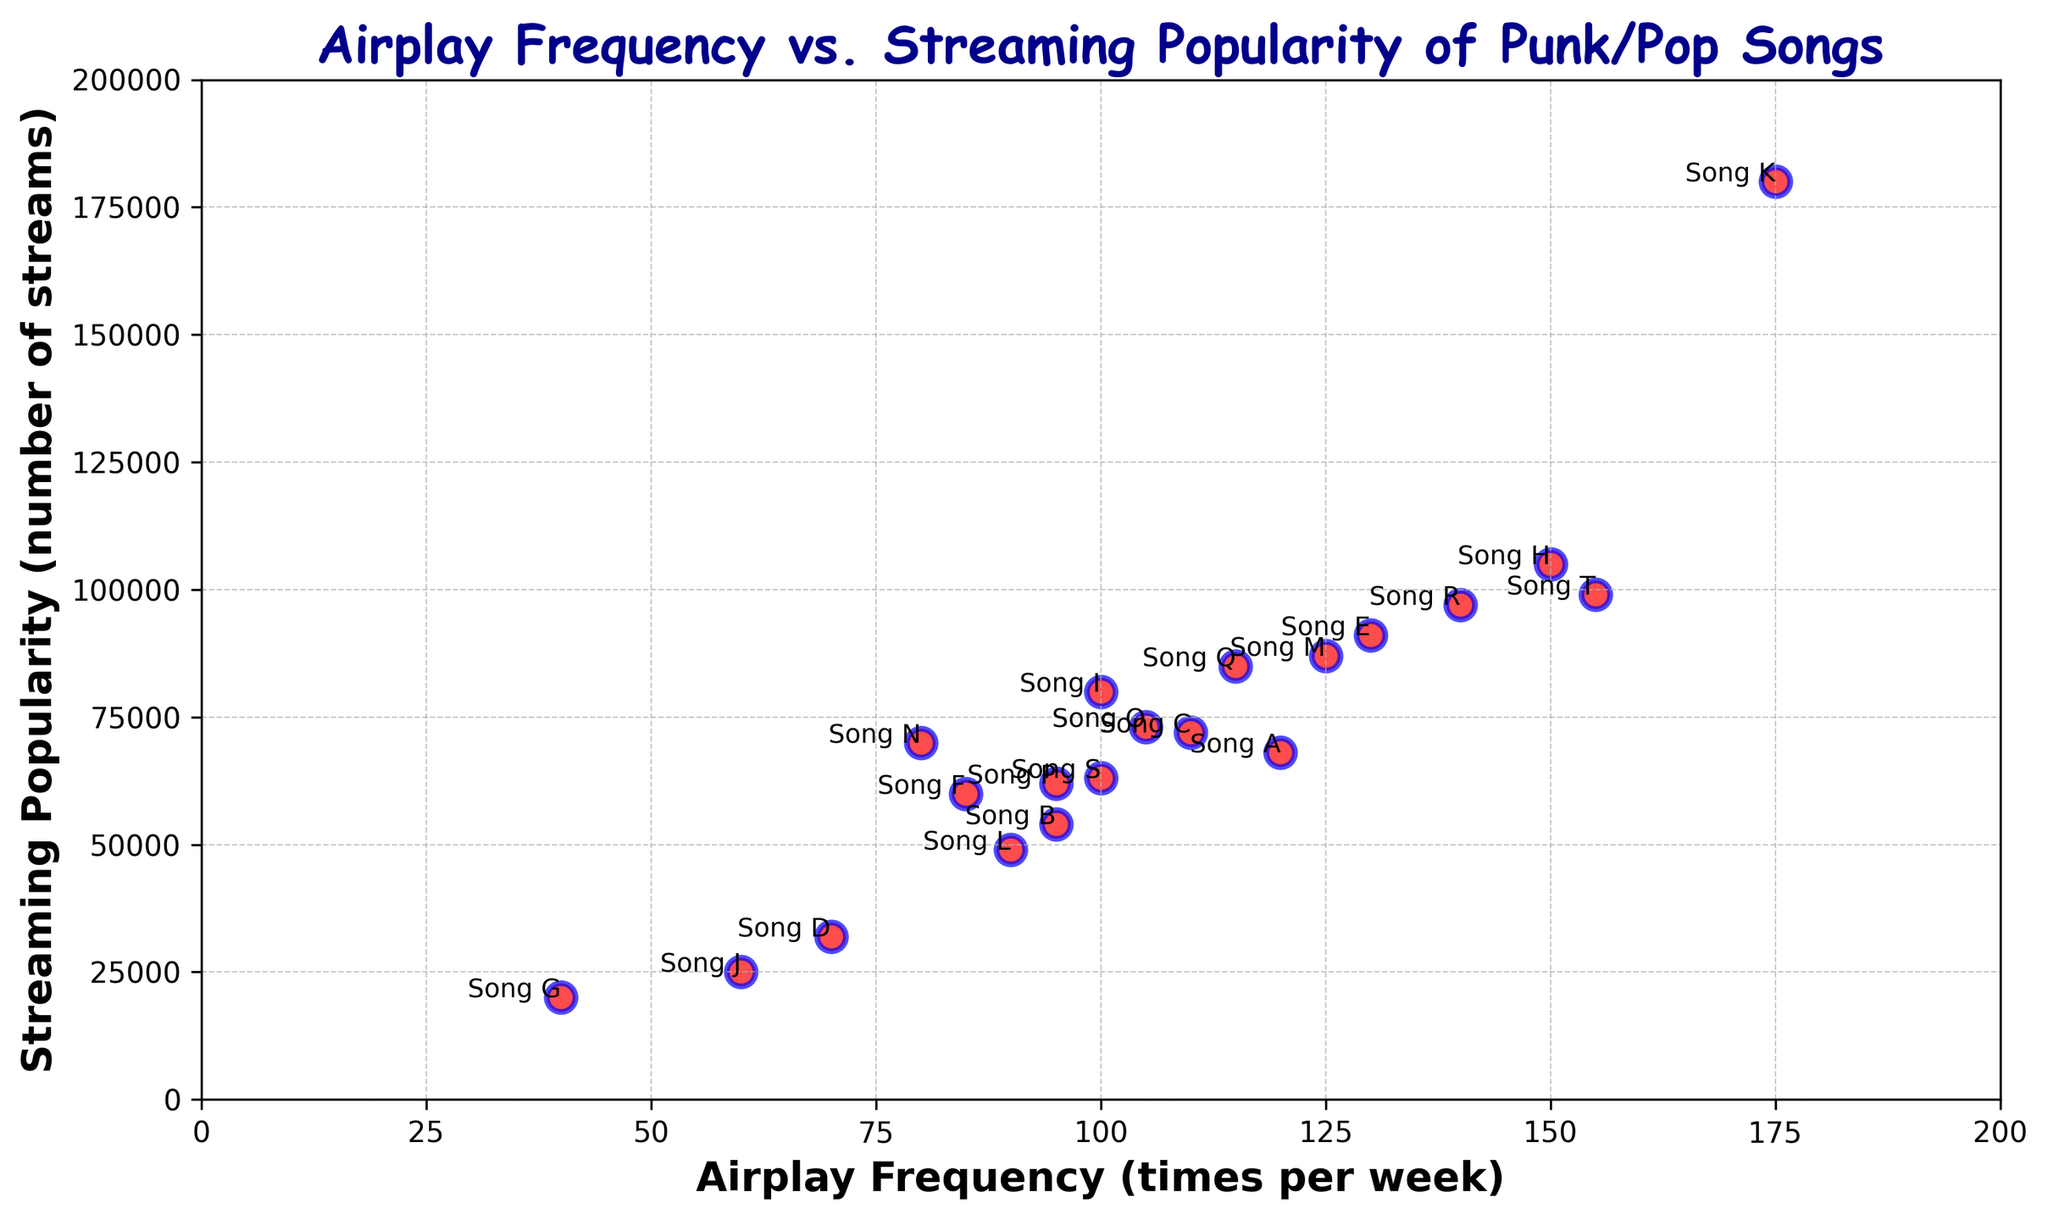What's the title with both the highest airplay frequency and streaming popularity? Identifying the point with the highest values on both axes can be done by visually checking the extreme points. The song with the highest airplay frequency (175) and highest streaming popularity (180000) is clearly marked as "Song K".
Answer: "Song K" Which song has more airplay frequency, "Song H" or "Song T"? Compare the x-axis positions of their labeled points. "Song H" is at 150 and "Song T" is at 155 on the x-axis. Therefore, "Song T" has more airplay frequency.
Answer: "Song T" Which title falls in the bottom left corner, indicating low airplay frequency and low streaming popularity? Examine the plot for the point that is closest to the origin (0,0). "Song G", with an airplay frequency of 40 and streaming popularity of 20000, fits this description.
Answer: "Song G" Is there a correlation between airplay frequency and streaming popularity visible in the plot? To determine correlation, observe the overall trend in the scatter plot. Most points ascend diagonally from bottom left to top right, indicating a positive correlation; as airplay frequency increases, streaming popularity tends to increase.
Answer: Yes What's the average airplay frequency of the four songs with the highest streaming popularity? Identify the top four songs by streaming popularity: "Song K" (180000), "Song H" (105000), "Song T" (99000), and "Song R" (97000). Their airplay frequencies are 175, 150, 155, and 140 respectively. The average is calculated as (175+150+155+140)/4 = 620/4.
Answer: 155 How much more popular in streaming is "Song H" compared to "Song S"? Locate "Song H" (105000 streams) and "Song S" (63000 streams) in the plot. Calculate the difference in their y-axis values: 105000 - 63000 = 42000.
Answer: 42000 Which song with an airplay frequency between 90 to 110 has the highest streaming popularity? Focus on songs within the x-axis range of 90 to 110: "Song B", "Song C", "Song I", "Song O", and "Song P". "Song C" has the highest streaming popularity among them with 72000.
Answer: "Song C" How many songs have an airplay frequency above 100 and a streaming popularity below 80000? Check the plot for points with x-values above 100 and y-values below 80000, namely: "Song O" (73000), "Song Q" (85000 but above threshold). Only one song fits: "Song O".
Answer: 1 Which song breaks the trend of higher airplay frequency generally leading to higher streaming popularity? Identify any points that notably deviate from the trend. "Song D" has lower streaming popularity (32000) despite being placed relatively higher for airplay frequency (70) compared to its peers.
Answer: "Song D" By how much does the most streamed song exceed the second most streamed song? The most streamed song "Song K" has 180000 streams, and the second highest, "Song H" has 105000 streams. The difference is 180000 - 105000 = 75000.
Answer: 75000 